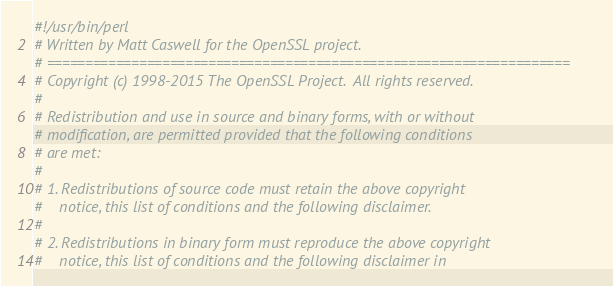<code> <loc_0><loc_0><loc_500><loc_500><_Perl_>#!/usr/bin/perl
# Written by Matt Caswell for the OpenSSL project.
# ====================================================================
# Copyright (c) 1998-2015 The OpenSSL Project.  All rights reserved.
#
# Redistribution and use in source and binary forms, with or without
# modification, are permitted provided that the following conditions
# are met:
#
# 1. Redistributions of source code must retain the above copyright
#    notice, this list of conditions and the following disclaimer.
#
# 2. Redistributions in binary form must reproduce the above copyright
#    notice, this list of conditions and the following disclaimer in</code> 